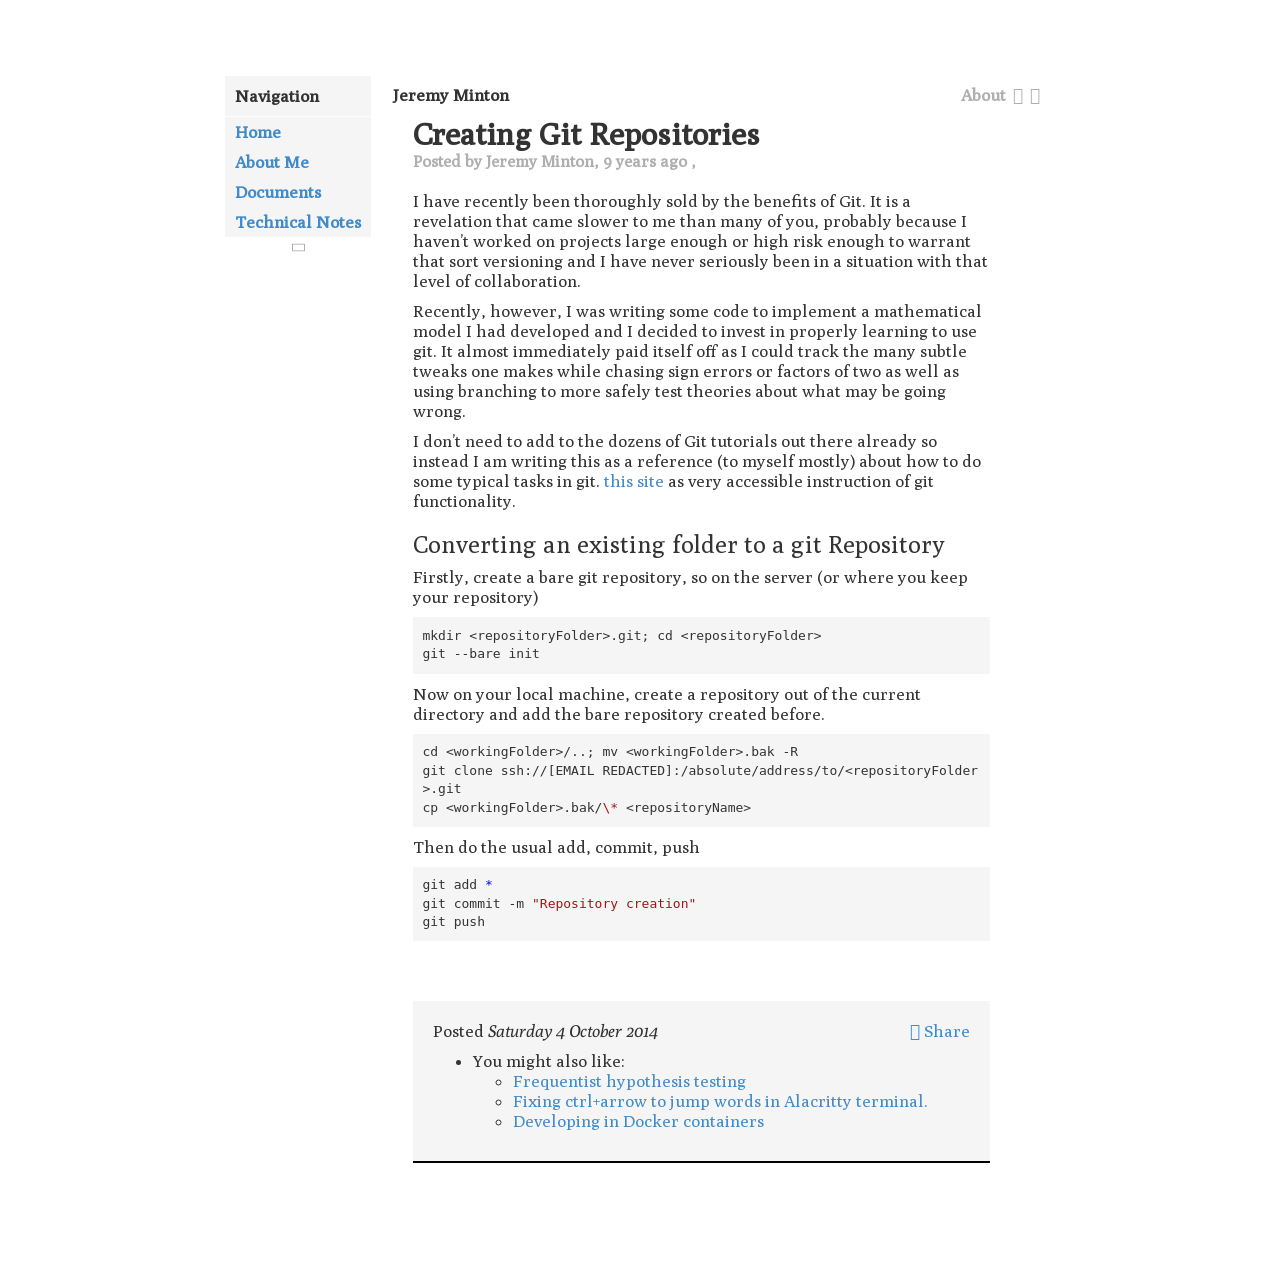What software tool is heavily recommended on this webpage for version control? The software tool recommended for version control on this webpage is Git, which is widely used by developers for managing project versions effectively.  Are there any other learning resources or related topics mentioned on the webpage? Yes, the webpage mentions additional resources and related topics such as frequentist hypothesis testing, fixing ctrl+arrow for word jumping in Alacritty terminal, and developing in Docker containers, providing a well-rounded educational resource for readers. 